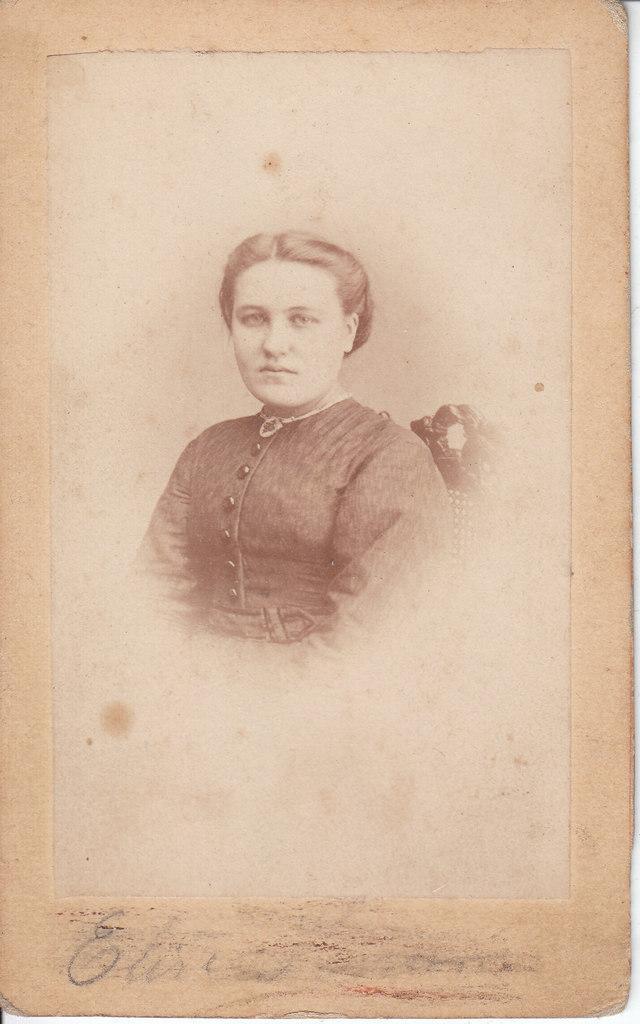In one or two sentences, can you explain what this image depicts? This is a paper. In the center of the image we can see a lady, chair. At the bottom of the image we can see some text. 